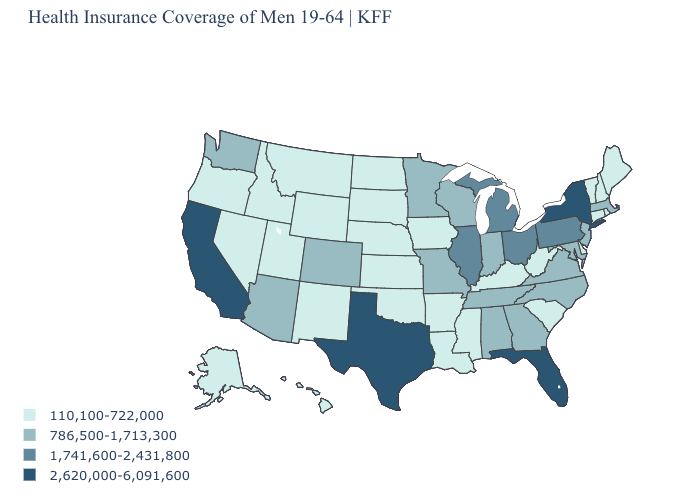What is the highest value in the South ?
Give a very brief answer. 2,620,000-6,091,600. Name the states that have a value in the range 1,741,600-2,431,800?
Concise answer only. Illinois, Michigan, Ohio, Pennsylvania. What is the value of Iowa?
Be succinct. 110,100-722,000. Does the map have missing data?
Answer briefly. No. Is the legend a continuous bar?
Give a very brief answer. No. What is the lowest value in the USA?
Short answer required. 110,100-722,000. Does Illinois have the lowest value in the MidWest?
Give a very brief answer. No. Name the states that have a value in the range 110,100-722,000?
Keep it brief. Alaska, Arkansas, Connecticut, Delaware, Hawaii, Idaho, Iowa, Kansas, Kentucky, Louisiana, Maine, Mississippi, Montana, Nebraska, Nevada, New Hampshire, New Mexico, North Dakota, Oklahoma, Oregon, Rhode Island, South Carolina, South Dakota, Utah, Vermont, West Virginia, Wyoming. What is the value of South Carolina?
Short answer required. 110,100-722,000. What is the value of New Jersey?
Give a very brief answer. 786,500-1,713,300. What is the highest value in states that border New York?
Write a very short answer. 1,741,600-2,431,800. Name the states that have a value in the range 2,620,000-6,091,600?
Concise answer only. California, Florida, New York, Texas. Name the states that have a value in the range 2,620,000-6,091,600?
Write a very short answer. California, Florida, New York, Texas. What is the lowest value in the South?
Quick response, please. 110,100-722,000. What is the lowest value in the MidWest?
Keep it brief. 110,100-722,000. 